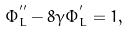Convert formula to latex. <formula><loc_0><loc_0><loc_500><loc_500>\Phi _ { L } ^ { ^ { \prime \prime } } - 8 \gamma \Phi _ { L } ^ { ^ { \prime } } = 1 ,</formula> 